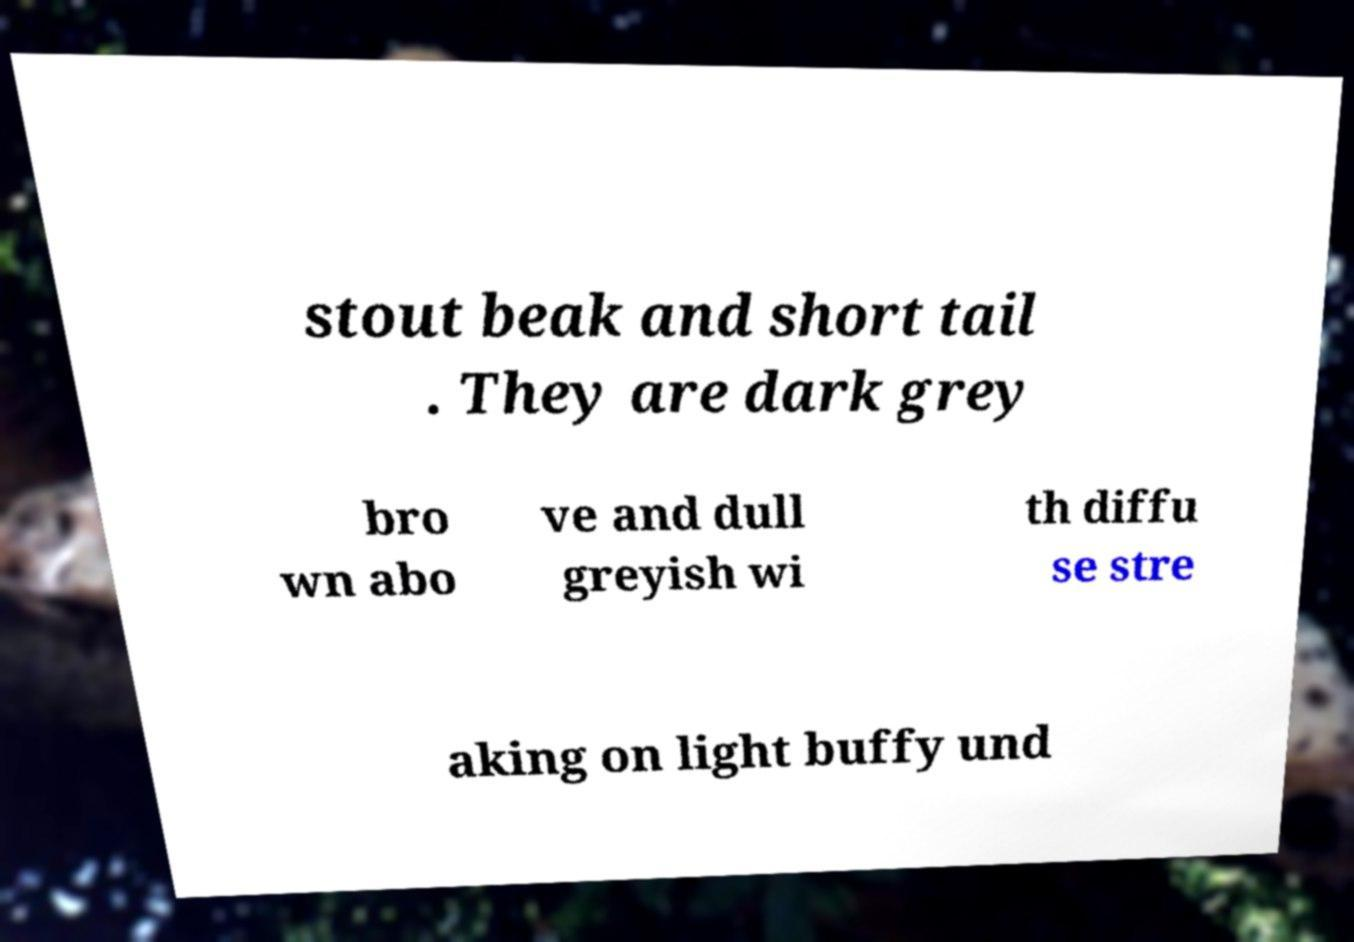Could you assist in decoding the text presented in this image and type it out clearly? stout beak and short tail . They are dark grey bro wn abo ve and dull greyish wi th diffu se stre aking on light buffy und 